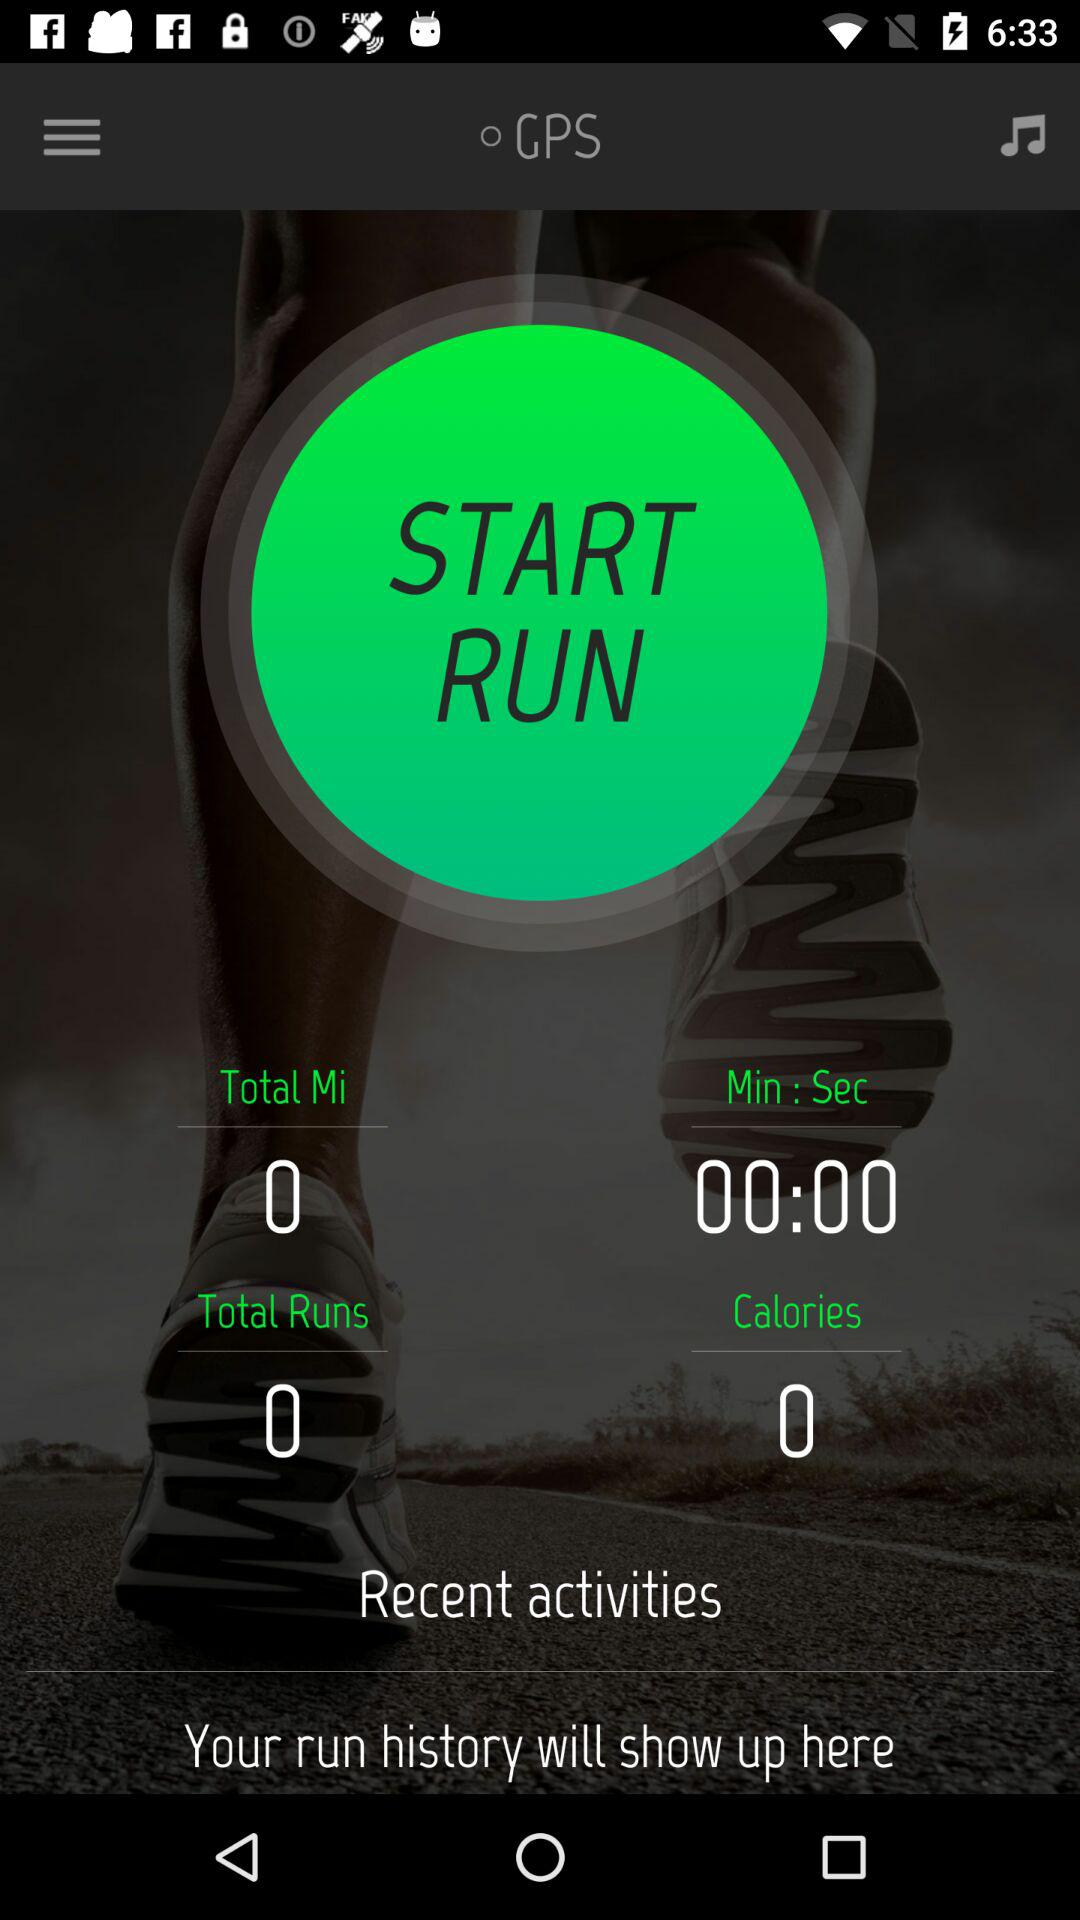What's the total count of runs? The total count of runs is 0. 